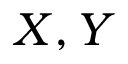Convert formula to latex. <formula><loc_0><loc_0><loc_500><loc_500>X , Y</formula> 